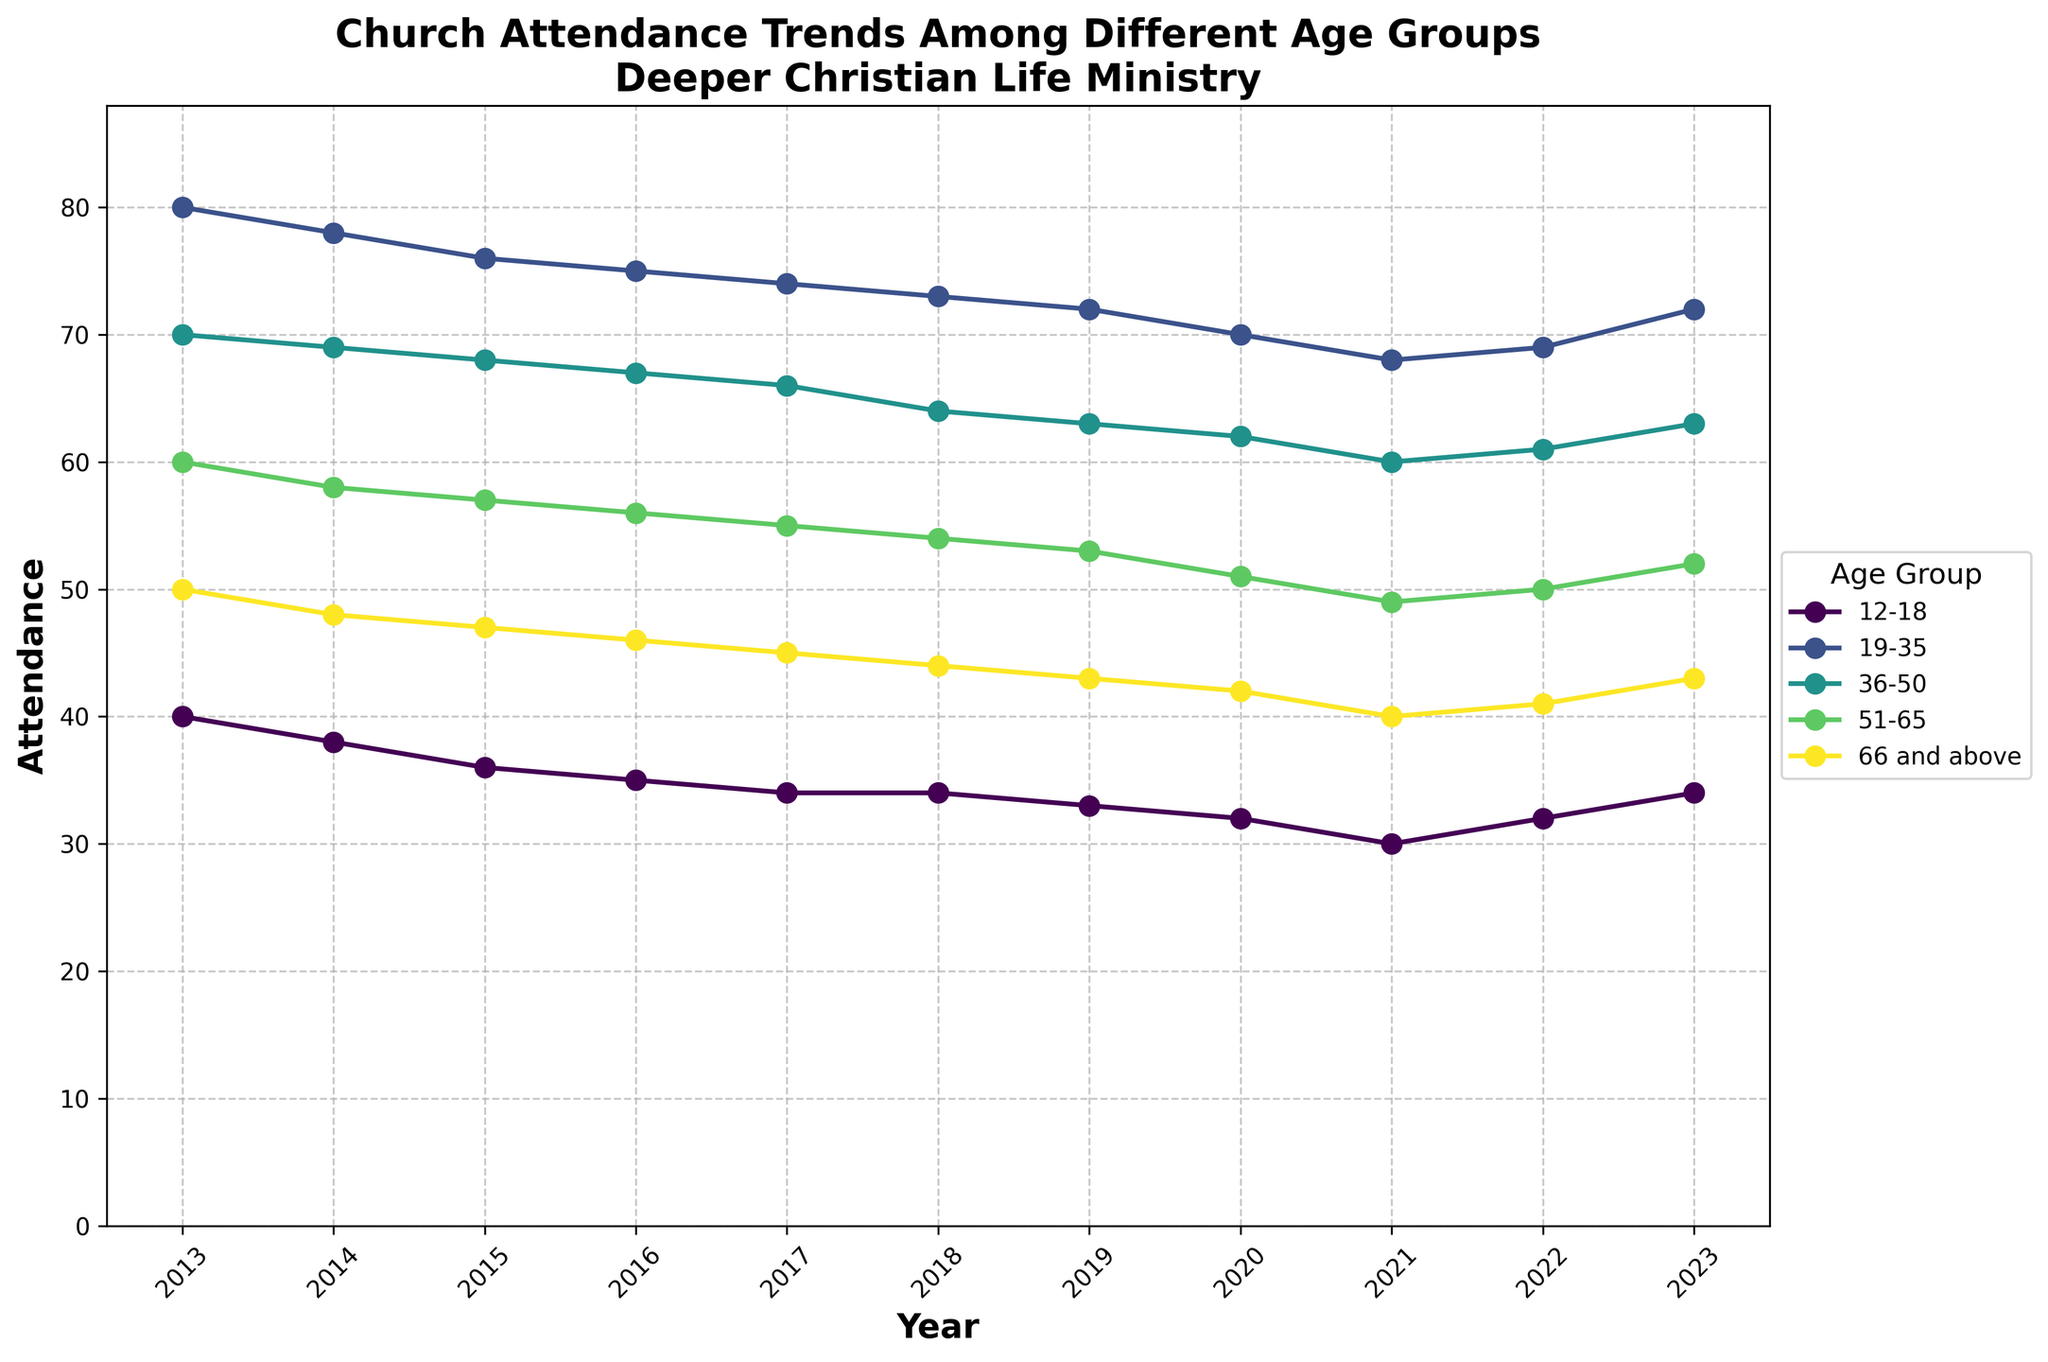What is the title of the plot? The title of the plot is located at the top of the figure and provides an overview of the data being displayed. In this case, it reads "Church Attendance Trends Among Different Age Groups\nDeeper Christian Life Ministry".
Answer: Church Attendance Trends Among Different Age Groups\nDeeper Christian Life Ministry Which age group has the highest attendance in 2023? To determine this, look at the 2023 data points on the plot and locate the one with the highest y-value. The age group with the highest y-value in 2023 should be noted.
Answer: 19-35 Which age group saw the most significant decrease in attendance from 2013 to 2023? Compare the attendance values for each age group in 2013 and 2023. The group with the largest difference (2013 value - 2023 value) experienced the most significant decrease.
Answer: 12-18 How many age groups are represented in the plot? Count the number of unique lines on the plot, each corresponding to a different age group.
Answer: 5 What is the general trend in attendance for the age group 51-65 over the last decade? Identify the points corresponding to the age group 51-65 and observe their trajectory from 2013 to 2023 to identify the overall trend.
Answer: Decreasing Which year saw the lowest attendance for the 66 and above age group? Look for the data point with the lowest y-value for the age group 66 and above. The corresponding x-value (year) identifies the year with the lowest attendance.
Answer: 2021 Calculate the average attendance for the 36-50 age group from 2013 to 2023. Add up all attendance values for the age group 36-50 from 2013 to 2023 and divide by the number of years to get the average. Sum = 70 + 69 + 68 + 67 + 66 + 64 + 63 + 62 + 60 + 61 + 63 = 713, Number of years = 11. Average = 713 / 11.
Answer: 64.82 Compare the attendance trends for the 12-18 age group and the 19-35 age group from 2013 to 2023. Examine the lines representing these age groups and compare their trends over time—whether they are increasing, decreasing, or remaining stable.
Answer: 12-18 is decreasing, 19-35 is fluctuating What is the overall attendance trend for all age groups combined from 2013 to 2023? Sum the attendance figures for each year across all age groups and plot this combined attendance over time. Identify whether this combined value increases, decreases, or remains stable over the period.
Answer: Decreasing 